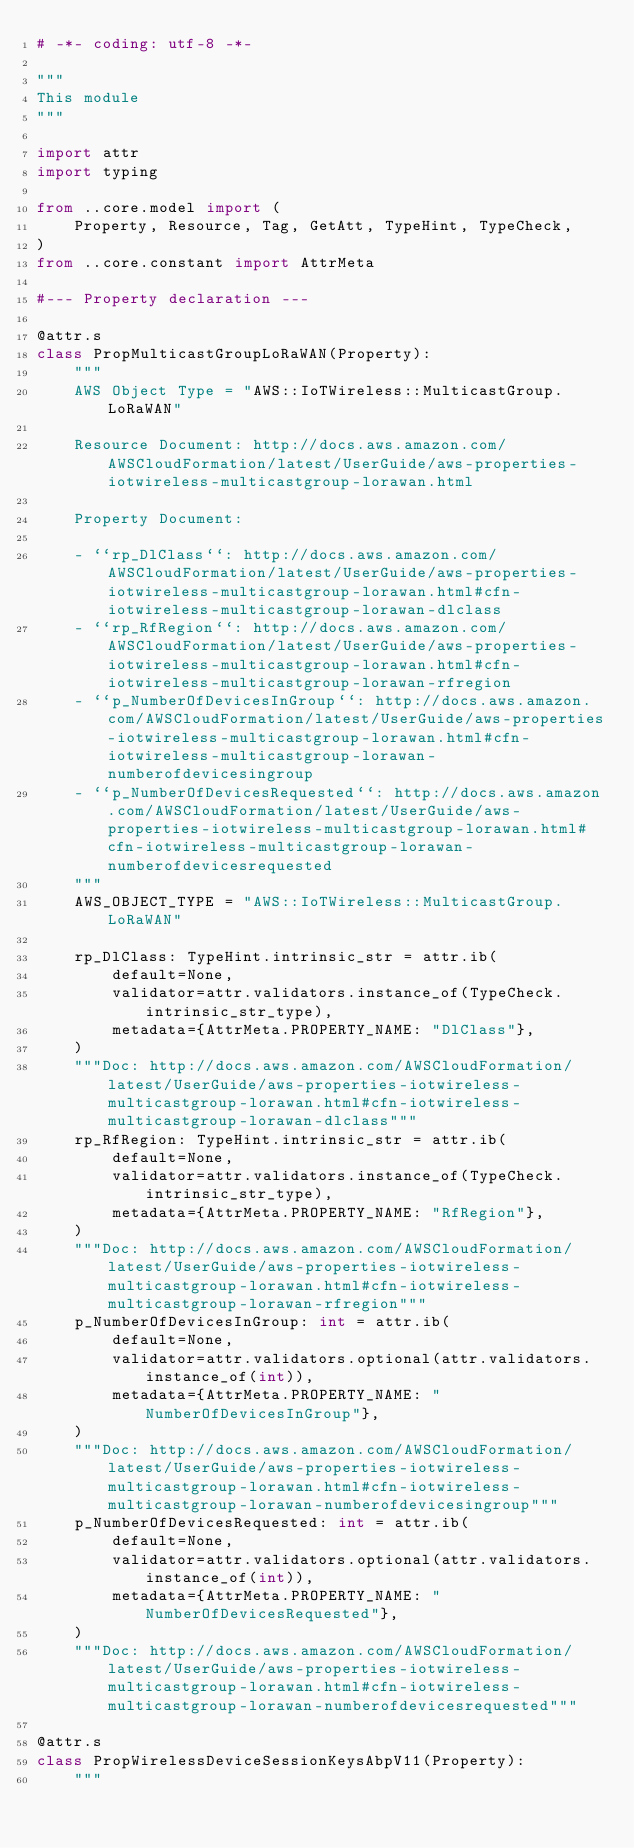Convert code to text. <code><loc_0><loc_0><loc_500><loc_500><_Python_># -*- coding: utf-8 -*-

"""
This module
"""

import attr
import typing

from ..core.model import (
    Property, Resource, Tag, GetAtt, TypeHint, TypeCheck,
)
from ..core.constant import AttrMeta

#--- Property declaration ---

@attr.s
class PropMulticastGroupLoRaWAN(Property):
    """
    AWS Object Type = "AWS::IoTWireless::MulticastGroup.LoRaWAN"

    Resource Document: http://docs.aws.amazon.com/AWSCloudFormation/latest/UserGuide/aws-properties-iotwireless-multicastgroup-lorawan.html

    Property Document:
    
    - ``rp_DlClass``: http://docs.aws.amazon.com/AWSCloudFormation/latest/UserGuide/aws-properties-iotwireless-multicastgroup-lorawan.html#cfn-iotwireless-multicastgroup-lorawan-dlclass
    - ``rp_RfRegion``: http://docs.aws.amazon.com/AWSCloudFormation/latest/UserGuide/aws-properties-iotwireless-multicastgroup-lorawan.html#cfn-iotwireless-multicastgroup-lorawan-rfregion
    - ``p_NumberOfDevicesInGroup``: http://docs.aws.amazon.com/AWSCloudFormation/latest/UserGuide/aws-properties-iotwireless-multicastgroup-lorawan.html#cfn-iotwireless-multicastgroup-lorawan-numberofdevicesingroup
    - ``p_NumberOfDevicesRequested``: http://docs.aws.amazon.com/AWSCloudFormation/latest/UserGuide/aws-properties-iotwireless-multicastgroup-lorawan.html#cfn-iotwireless-multicastgroup-lorawan-numberofdevicesrequested
    """
    AWS_OBJECT_TYPE = "AWS::IoTWireless::MulticastGroup.LoRaWAN"
    
    rp_DlClass: TypeHint.intrinsic_str = attr.ib(
        default=None,
        validator=attr.validators.instance_of(TypeCheck.intrinsic_str_type),
        metadata={AttrMeta.PROPERTY_NAME: "DlClass"},
    )
    """Doc: http://docs.aws.amazon.com/AWSCloudFormation/latest/UserGuide/aws-properties-iotwireless-multicastgroup-lorawan.html#cfn-iotwireless-multicastgroup-lorawan-dlclass"""
    rp_RfRegion: TypeHint.intrinsic_str = attr.ib(
        default=None,
        validator=attr.validators.instance_of(TypeCheck.intrinsic_str_type),
        metadata={AttrMeta.PROPERTY_NAME: "RfRegion"},
    )
    """Doc: http://docs.aws.amazon.com/AWSCloudFormation/latest/UserGuide/aws-properties-iotwireless-multicastgroup-lorawan.html#cfn-iotwireless-multicastgroup-lorawan-rfregion"""
    p_NumberOfDevicesInGroup: int = attr.ib(
        default=None,
        validator=attr.validators.optional(attr.validators.instance_of(int)),
        metadata={AttrMeta.PROPERTY_NAME: "NumberOfDevicesInGroup"},
    )
    """Doc: http://docs.aws.amazon.com/AWSCloudFormation/latest/UserGuide/aws-properties-iotwireless-multicastgroup-lorawan.html#cfn-iotwireless-multicastgroup-lorawan-numberofdevicesingroup"""
    p_NumberOfDevicesRequested: int = attr.ib(
        default=None,
        validator=attr.validators.optional(attr.validators.instance_of(int)),
        metadata={AttrMeta.PROPERTY_NAME: "NumberOfDevicesRequested"},
    )
    """Doc: http://docs.aws.amazon.com/AWSCloudFormation/latest/UserGuide/aws-properties-iotwireless-multicastgroup-lorawan.html#cfn-iotwireless-multicastgroup-lorawan-numberofdevicesrequested"""

@attr.s
class PropWirelessDeviceSessionKeysAbpV11(Property):
    """</code> 